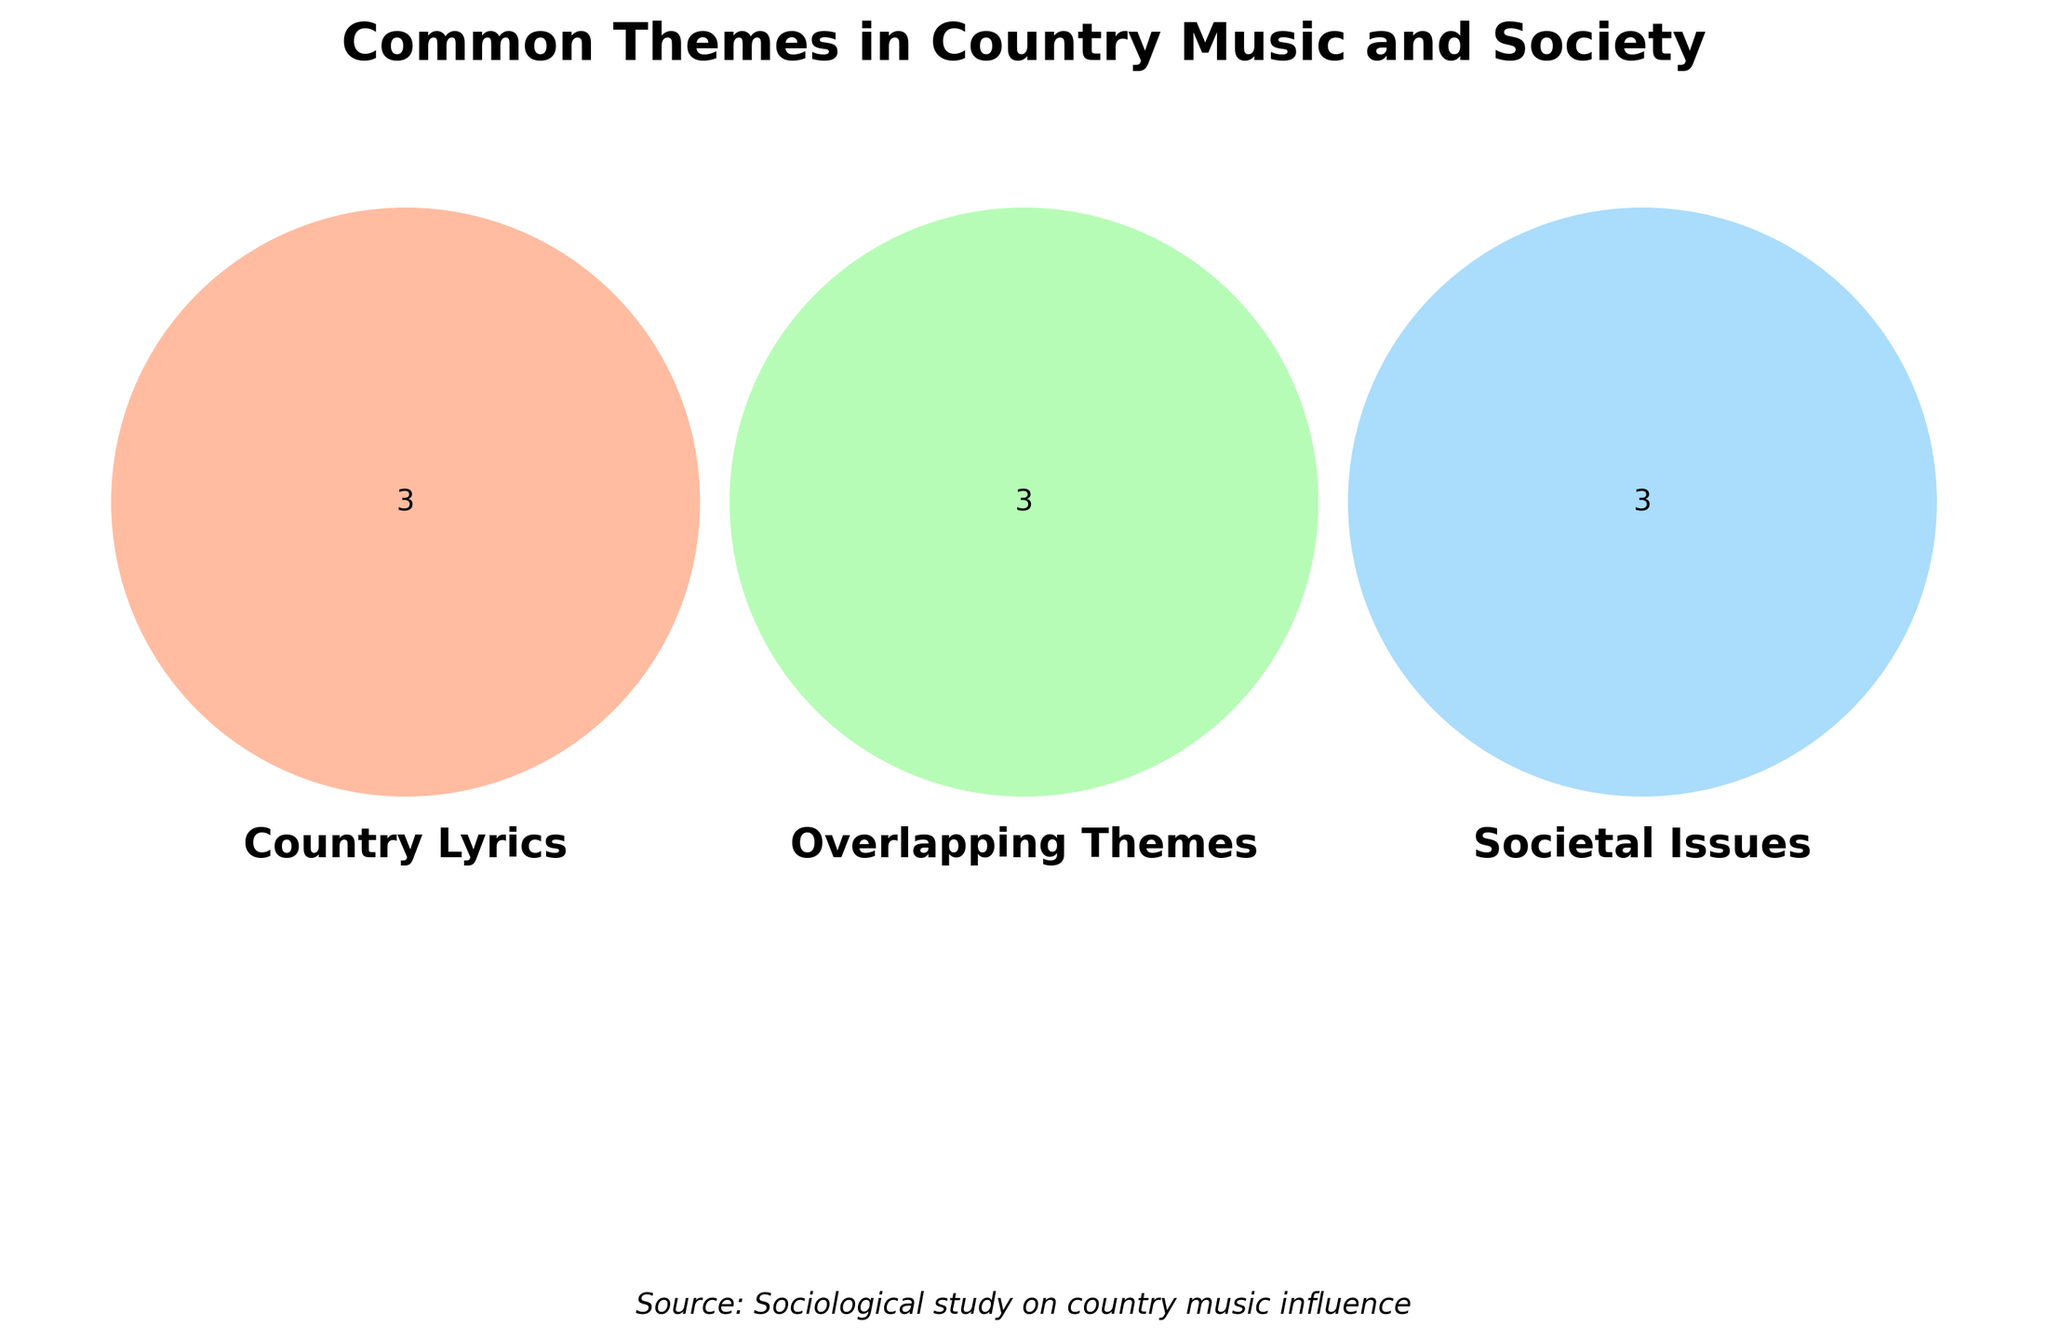What are the three main sets represented in the Venn diagram? The Venn diagram represents three sets labeled: 'Country Lyrics', 'Overlapping Themes', and 'Societal Issues'. The titles of these sets can be directly read off from the labels within the Venn diagram.
Answer: 'Country Lyrics', 'Overlapping Themes', 'Societal Issues' Which topic is only present in the 'Societal Issues' set? By looking at the part of the Venn diagram that represents only 'Societal Issues', one can see that 'Drug addiction' is a topic present exclusively in this set. This region does not intersect with the other two sets.
Answer: Drug addiction Which topics are shared between 'Country Lyrics' and 'Societal Issues' but not 'Overlapping Themes'? The intersection area between 'Country Lyrics' and 'Societal Issues' that does not overlap with 'Overlapping Themes' has only one topic shared: 'Pickup trucks'.
Answer: Pickup trucks Find a topic that's common to all three sets. By checking the central intersection region where all three sets overlap in the Venn diagram, one can find that 'Nostalgia' is listed as common to 'Country Lyrics', 'Overlapping Themes', and 'Societal Issues'.
Answer: Nostalgia Compare the number of topics exclusive to 'Country Lyrics' with those exclusive to 'Societal Issues'. Which has more? Counting the topics in the Venn diagram exclusively in the 'Country Lyrics' set versus those in the 'Societal Issues' set, 'Country Lyrics' has one exclusive topic ('Family values'), while 'Societal Issues' has one exclusive topic ('Drug addiction'). Both sets have an equal number of exclusive topics.
Answer: Both have 1 Which theme links 'Country Lyrics' to 'Overlapping Themes' but not 'Societal Issues'? The portion of the Venn diagram that represents the intersection of 'Country Lyrics' and 'Overlapping Themes', while excluding 'Societal Issues', contains 'Patriotism'.
Answer: Patriotism How many topics overlap between 'Overlapping Themes' and 'Societal Issues'? By looking at the intersection between 'Overlapping Themes' and 'Societal Issues', and excluding 'Country Lyrics', there are three topics: 'Nostalgia', 'Rural life', and 'Tradition vs. progress'.
Answer: 3 Which sets overlap with 'Urbanization'? 'Urbanization' is present in the 'Societal Issues' set but not in either 'Country Lyrics' or 'Overlapping Themes'. Therefore, it does not overlap with any other set.
Answer: None Identify a topic that's shared between 'Overlapping Themes' and 'Societal Issues' but not 'Country Lyrics', and explain why this is the case. The topics that fall into the shared region of 'Overlapping Themes' and 'Societal Issues' but not 'Country Lyrics' include 'Tradition vs. progress'. This is because this topic appears in the overlapping areas of the two sets without including elements from 'Country Lyrics'.
Answer: Tradition vs. progress 